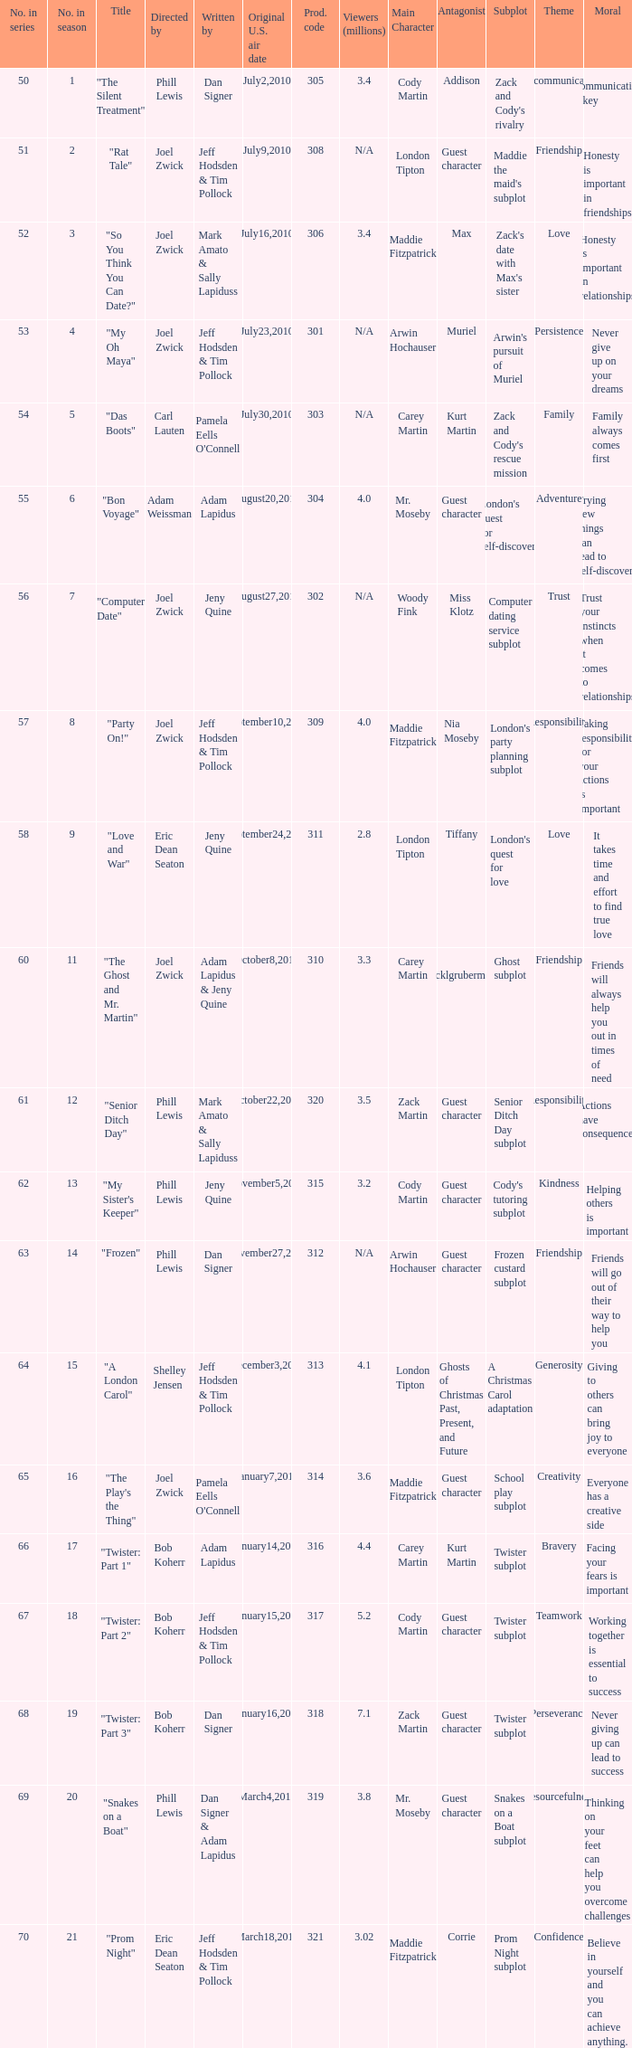Which US air date had 4.4 million viewers? January14,2011. 